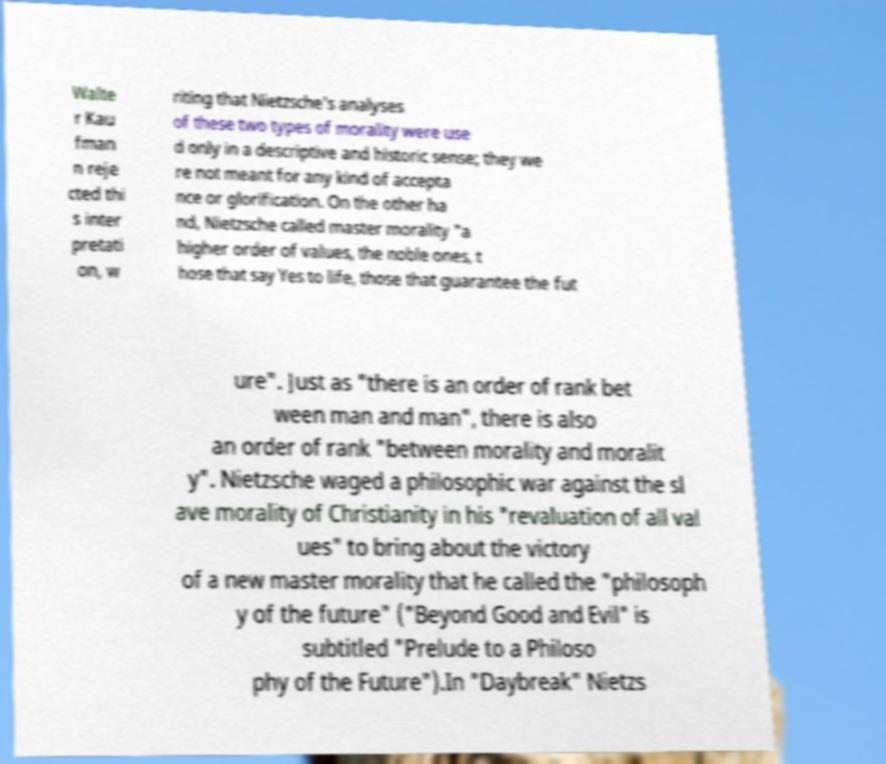Please read and relay the text visible in this image. What does it say? Walte r Kau fman n reje cted thi s inter pretati on, w riting that Nietzsche's analyses of these two types of morality were use d only in a descriptive and historic sense; they we re not meant for any kind of accepta nce or glorification. On the other ha nd, Nietzsche called master morality "a higher order of values, the noble ones, t hose that say Yes to life, those that guarantee the fut ure". Just as "there is an order of rank bet ween man and man", there is also an order of rank "between morality and moralit y". Nietzsche waged a philosophic war against the sl ave morality of Christianity in his "revaluation of all val ues" to bring about the victory of a new master morality that he called the "philosoph y of the future" ("Beyond Good and Evil" is subtitled "Prelude to a Philoso phy of the Future").In "Daybreak" Nietzs 